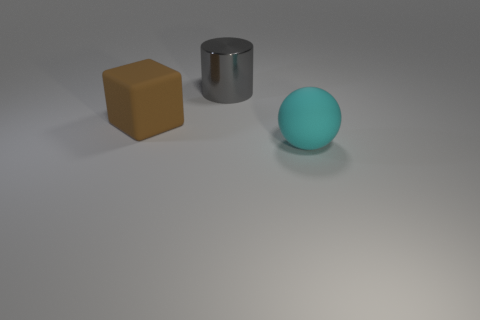Add 2 large blue cylinders. How many objects exist? 5 Subtract all cylinders. How many objects are left? 2 Add 3 cubes. How many cubes are left? 4 Add 1 tiny purple metal cubes. How many tiny purple metal cubes exist? 1 Subtract 0 blue balls. How many objects are left? 3 Subtract all big gray shiny things. Subtract all big metallic objects. How many objects are left? 1 